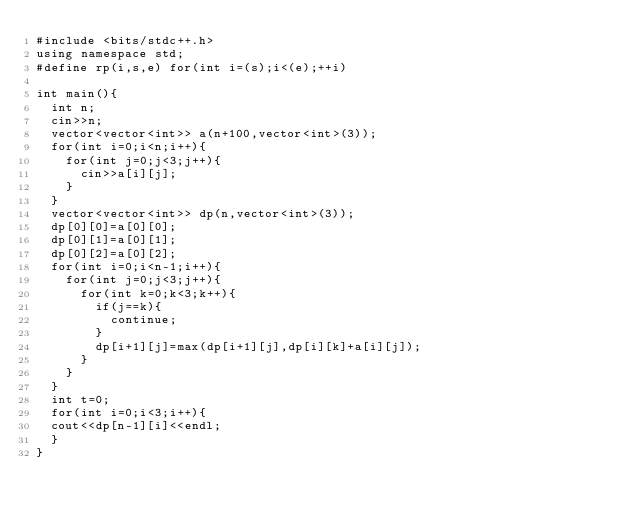Convert code to text. <code><loc_0><loc_0><loc_500><loc_500><_C++_>#include <bits/stdc++.h>
using namespace std;
#define rp(i,s,e) for(int i=(s);i<(e);++i)
 
int main(){
  int n;
  cin>>n;
  vector<vector<int>> a(n+100,vector<int>(3));
  for(int i=0;i<n;i++){
    for(int j=0;j<3;j++){
      cin>>a[i][j];
    }
  }
  vector<vector<int>> dp(n,vector<int>(3));
  dp[0][0]=a[0][0];
  dp[0][1]=a[0][1];
  dp[0][2]=a[0][2];
  for(int i=0;i<n-1;i++){
    for(int j=0;j<3;j++){
      for(int k=0;k<3;k++){
        if(j==k){
          continue;
        }
        dp[i+1][j]=max(dp[i+1][j],dp[i][k]+a[i][j]);
      }
    }
  }
  int t=0;
  for(int i=0;i<3;i++){
  cout<<dp[n-1][i]<<endl;
  }
}
</code> 